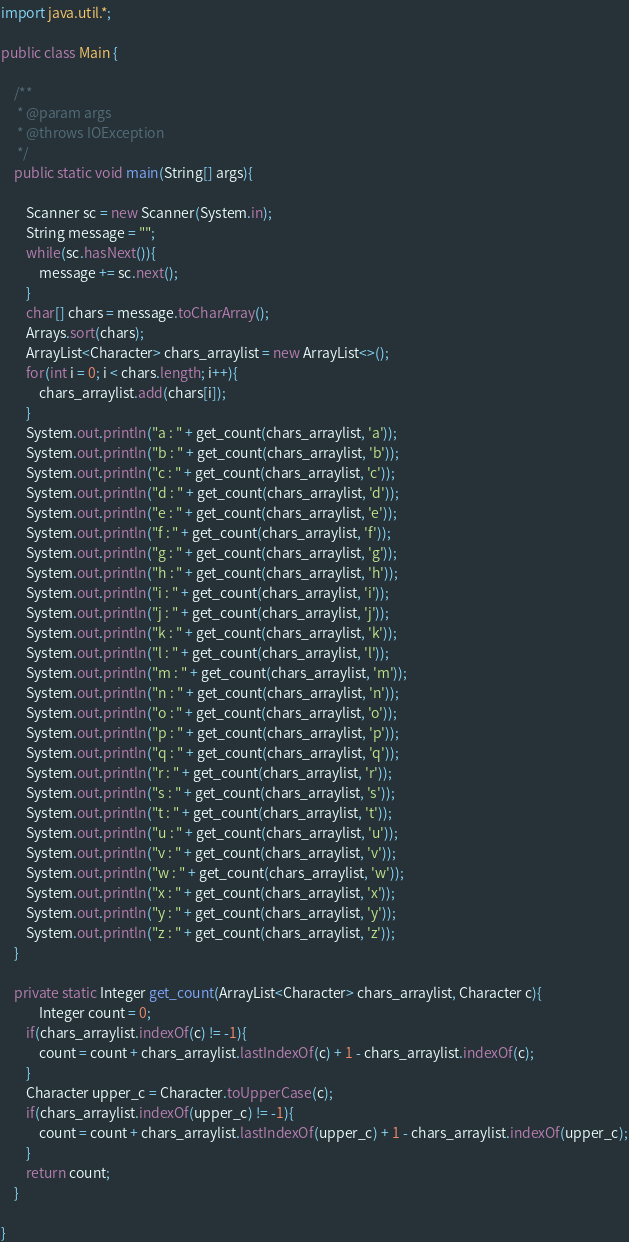Convert code to text. <code><loc_0><loc_0><loc_500><loc_500><_Java_>import java.util.*;

public class Main {

	/**
	 * @param args
	 * @throws IOException 
	 */
	public static void main(String[] args){

		Scanner sc = new Scanner(System.in);
		String message = "";
		while(sc.hasNext()){
			message += sc.next();
		}
		char[] chars = message.toCharArray();
		Arrays.sort(chars);
		ArrayList<Character> chars_arraylist = new ArrayList<>();
		for(int i = 0; i < chars.length; i++){
			chars_arraylist.add(chars[i]);
		}
		System.out.println("a : " + get_count(chars_arraylist, 'a'));
		System.out.println("b : " + get_count(chars_arraylist, 'b'));
		System.out.println("c : " + get_count(chars_arraylist, 'c'));
		System.out.println("d : " + get_count(chars_arraylist, 'd'));
		System.out.println("e : " + get_count(chars_arraylist, 'e'));
		System.out.println("f : " + get_count(chars_arraylist, 'f'));
		System.out.println("g : " + get_count(chars_arraylist, 'g'));
		System.out.println("h : " + get_count(chars_arraylist, 'h'));
		System.out.println("i : " + get_count(chars_arraylist, 'i'));
		System.out.println("j : " + get_count(chars_arraylist, 'j'));
		System.out.println("k : " + get_count(chars_arraylist, 'k'));
		System.out.println("l : " + get_count(chars_arraylist, 'l'));
		System.out.println("m : " + get_count(chars_arraylist, 'm'));
		System.out.println("n : " + get_count(chars_arraylist, 'n'));
		System.out.println("o : " + get_count(chars_arraylist, 'o'));
		System.out.println("p : " + get_count(chars_arraylist, 'p'));
		System.out.println("q : " + get_count(chars_arraylist, 'q'));
		System.out.println("r : " + get_count(chars_arraylist, 'r'));
		System.out.println("s : " + get_count(chars_arraylist, 's'));
		System.out.println("t : " + get_count(chars_arraylist, 't'));
		System.out.println("u : " + get_count(chars_arraylist, 'u'));
		System.out.println("v : " + get_count(chars_arraylist, 'v'));
		System.out.println("w : " + get_count(chars_arraylist, 'w'));
		System.out.println("x : " + get_count(chars_arraylist, 'x'));
		System.out.println("y : " + get_count(chars_arraylist, 'y'));
		System.out.println("z : " + get_count(chars_arraylist, 'z'));
	}

	private static Integer get_count(ArrayList<Character> chars_arraylist, Character c){
			Integer count = 0;
		if(chars_arraylist.indexOf(c) != -1){
			count = count + chars_arraylist.lastIndexOf(c) + 1 - chars_arraylist.indexOf(c);
		}
		Character upper_c = Character.toUpperCase(c);
		if(chars_arraylist.indexOf(upper_c) != -1){
			count = count + chars_arraylist.lastIndexOf(upper_c) + 1 - chars_arraylist.indexOf(upper_c);
		}
		return count;
	}

}</code> 